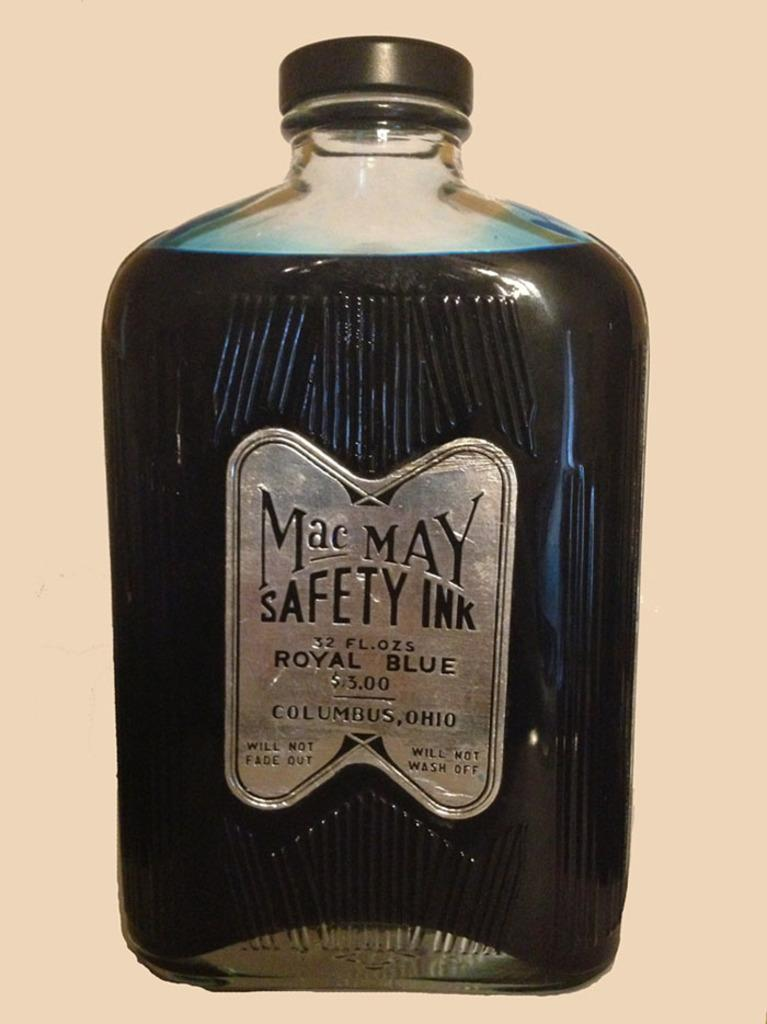<image>
Relay a brief, clear account of the picture shown. The bottle reads 'Mac May Safety Ink' and comes in a royal blue color. 